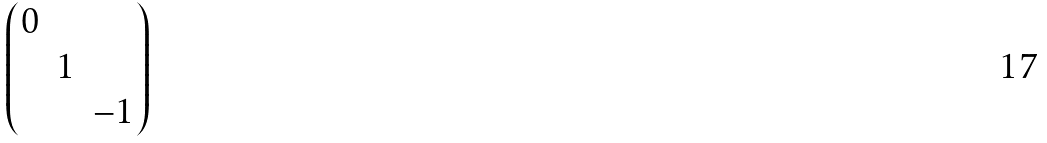Convert formula to latex. <formula><loc_0><loc_0><loc_500><loc_500>\begin{pmatrix} 0 & & \\ & 1 & \\ & & - 1 \end{pmatrix}</formula> 